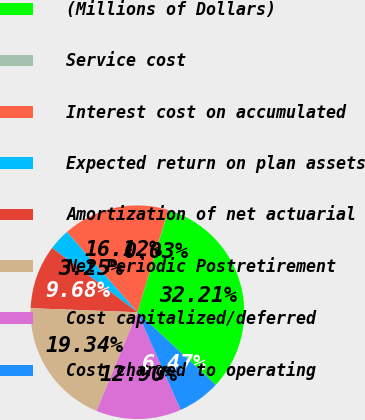<chart> <loc_0><loc_0><loc_500><loc_500><pie_chart><fcel>(Millions of Dollars)<fcel>Service cost<fcel>Interest cost on accumulated<fcel>Expected return on plan assets<fcel>Amortization of net actuarial<fcel>Net Periodic Postretirement<fcel>Cost capitalized/deferred<fcel>Cost charged to operating<nl><fcel>32.21%<fcel>0.03%<fcel>16.12%<fcel>3.25%<fcel>9.68%<fcel>19.34%<fcel>12.9%<fcel>6.47%<nl></chart> 